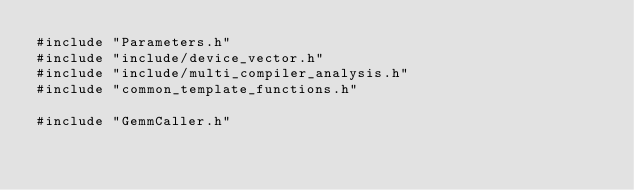<code> <loc_0><loc_0><loc_500><loc_500><_Cuda_>#include "Parameters.h"
#include "include/device_vector.h"
#include "include/multi_compiler_analysis.h"
#include "common_template_functions.h"

#include "GemmCaller.h"
</code> 